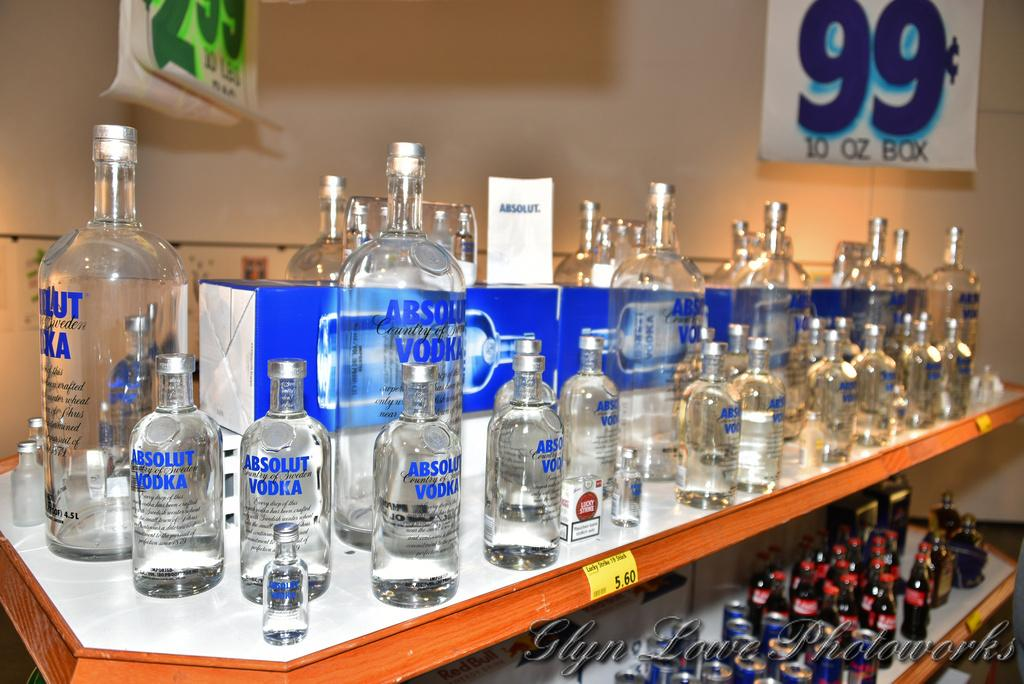<image>
Write a terse but informative summary of the picture. A bunch of Vodka bottles sit on the shelf with a large 99 cents sign in the back. 